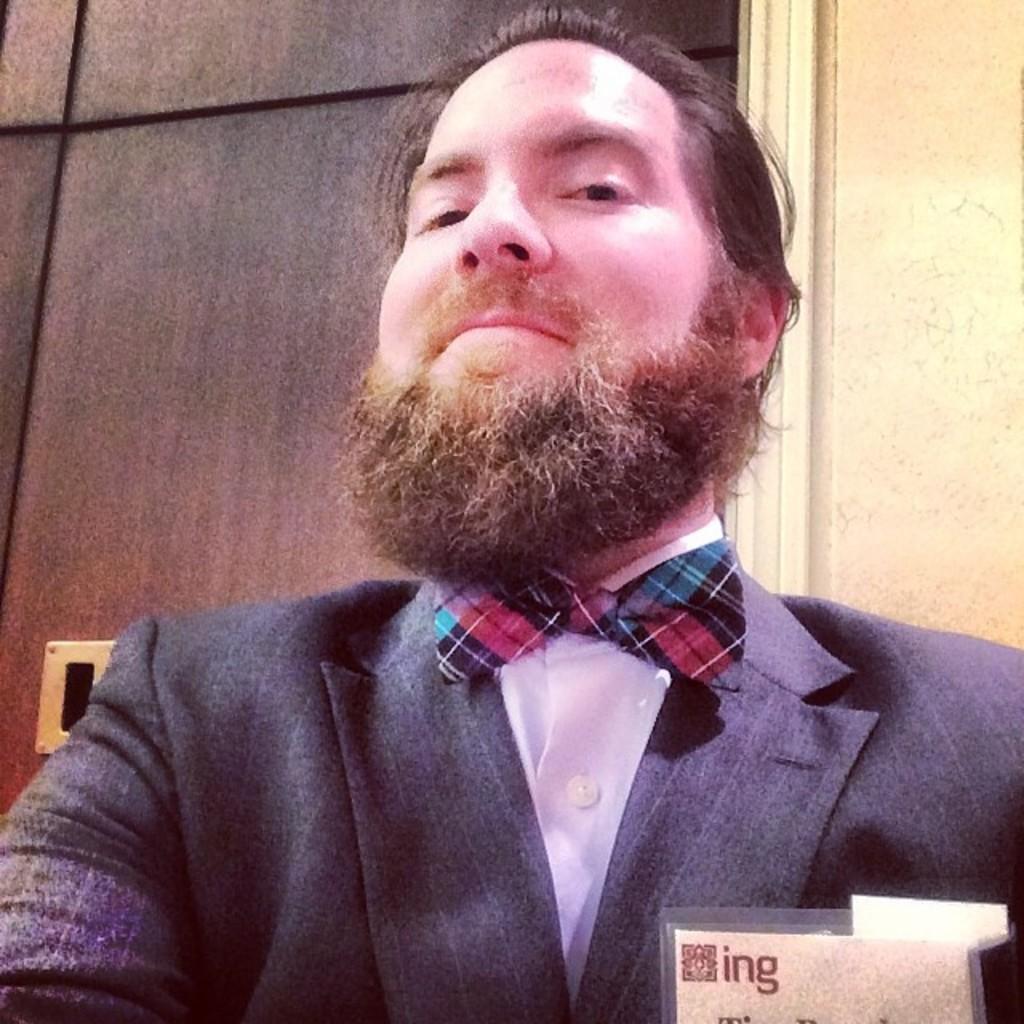Could you give a brief overview of what you see in this image? In this image we can see a man and in the background we can see a door and wall. At the bottom we can see a card. 